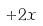Convert formula to latex. <formula><loc_0><loc_0><loc_500><loc_500>+ 2 x</formula> 